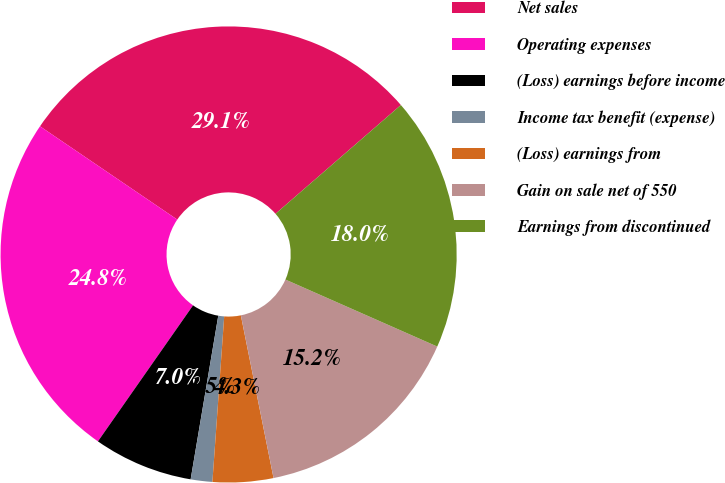<chart> <loc_0><loc_0><loc_500><loc_500><pie_chart><fcel>Net sales<fcel>Operating expenses<fcel>(Loss) earnings before income<fcel>Income tax benefit (expense)<fcel>(Loss) earnings from<fcel>Gain on sale net of 550<fcel>Earnings from discontinued<nl><fcel>29.13%<fcel>24.79%<fcel>7.05%<fcel>1.53%<fcel>4.29%<fcel>15.23%<fcel>17.99%<nl></chart> 